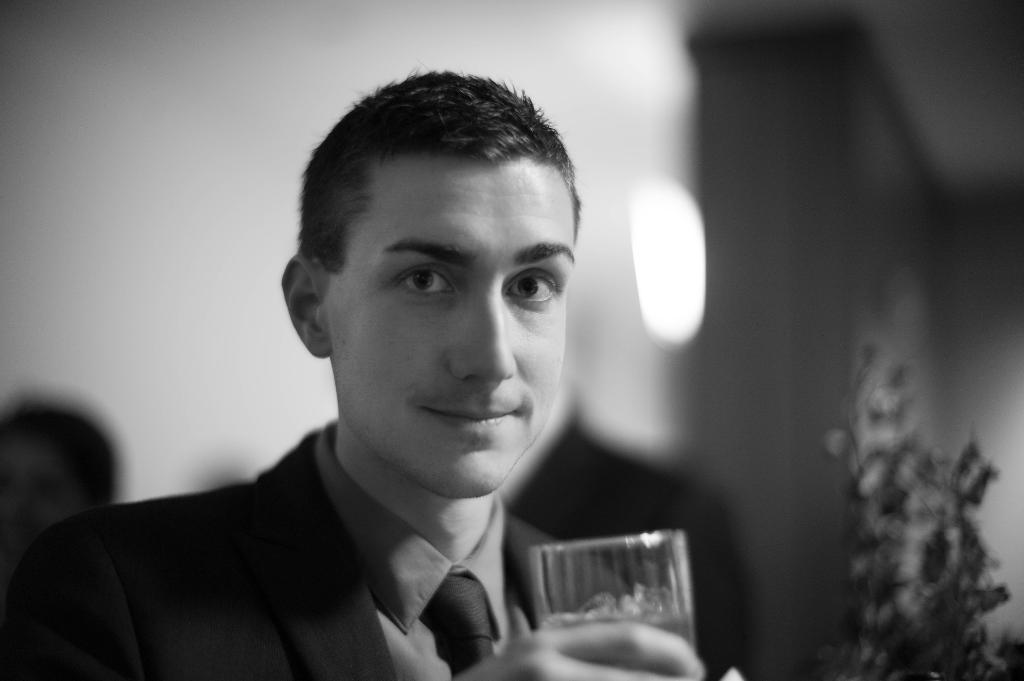Please provide a concise description of this image. In this image I can see a person holding glass, at right I can see a plant, at the background I can see a wall and the image is in black and white. 